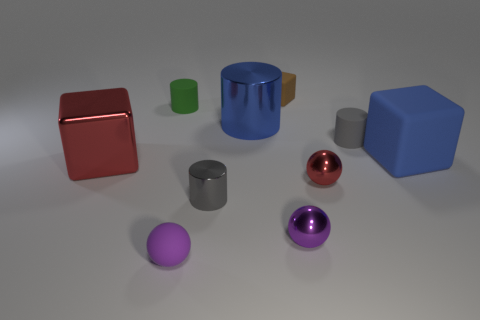Can you tell me the colors of the sphere-shaped objects in the image? Certainly! In the image, there are two spheres; one is purple and the other is a shiny reflective color that closely resembles pink or rose gold. 